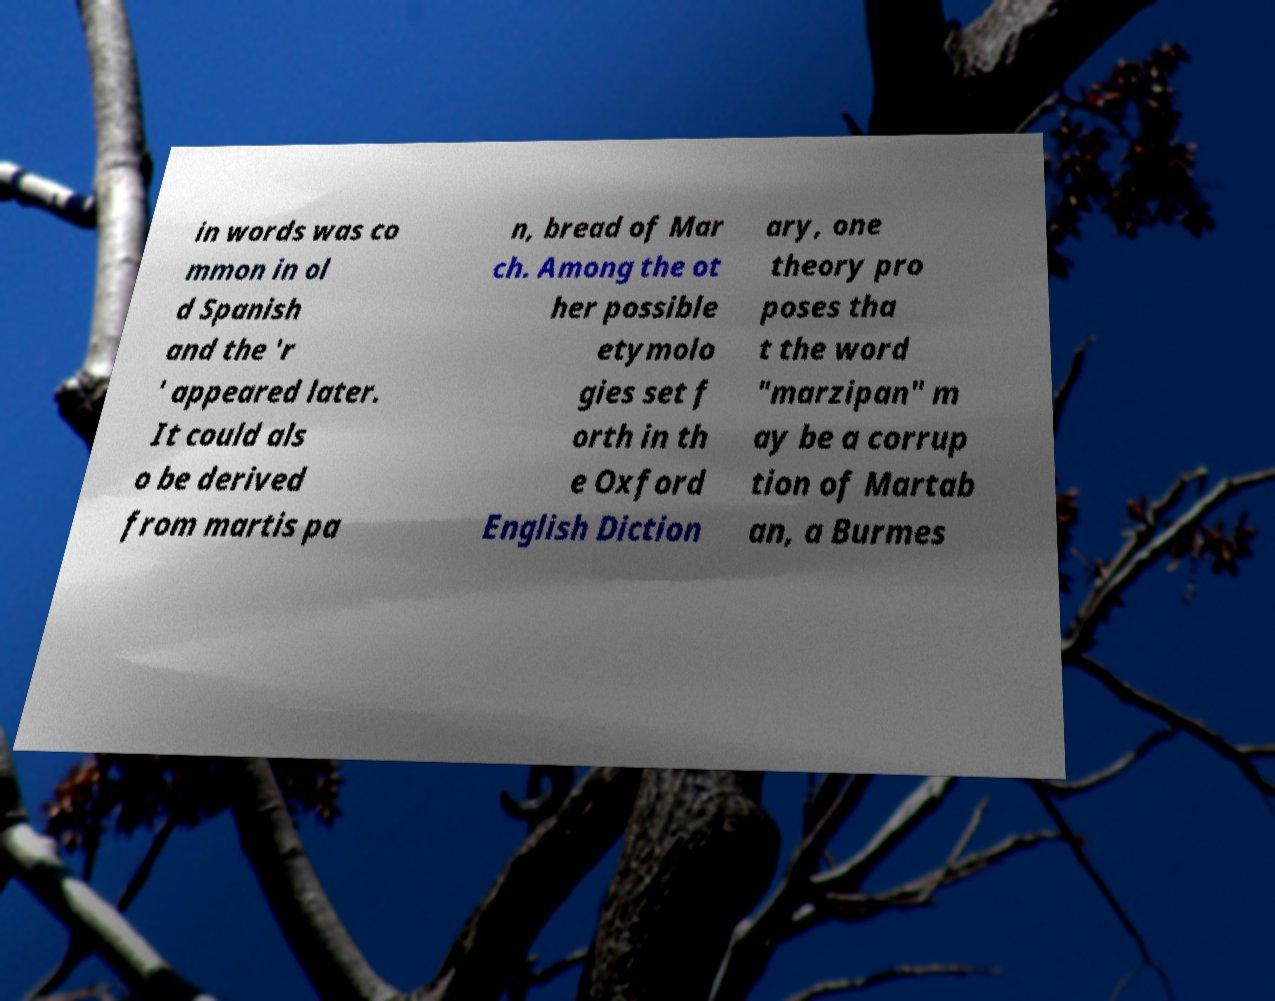Can you read and provide the text displayed in the image?This photo seems to have some interesting text. Can you extract and type it out for me? in words was co mmon in ol d Spanish and the 'r ' appeared later. It could als o be derived from martis pa n, bread of Mar ch. Among the ot her possible etymolo gies set f orth in th e Oxford English Diction ary, one theory pro poses tha t the word "marzipan" m ay be a corrup tion of Martab an, a Burmes 